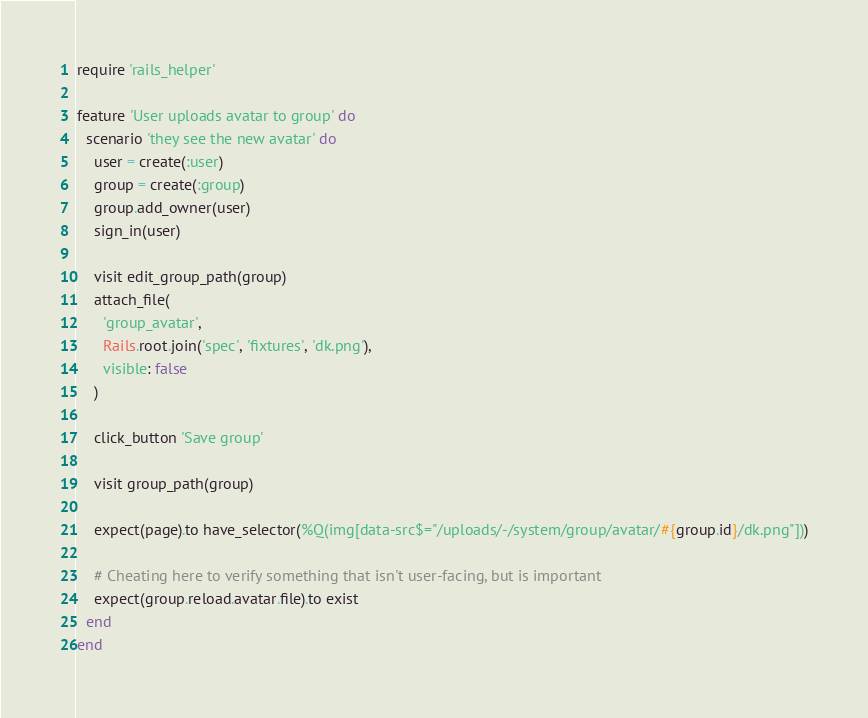<code> <loc_0><loc_0><loc_500><loc_500><_Ruby_>require 'rails_helper'

feature 'User uploads avatar to group' do
  scenario 'they see the new avatar' do
    user = create(:user)
    group = create(:group)
    group.add_owner(user)
    sign_in(user)

    visit edit_group_path(group)
    attach_file(
      'group_avatar',
      Rails.root.join('spec', 'fixtures', 'dk.png'),
      visible: false
    )

    click_button 'Save group'

    visit group_path(group)

    expect(page).to have_selector(%Q(img[data-src$="/uploads/-/system/group/avatar/#{group.id}/dk.png"]))

    # Cheating here to verify something that isn't user-facing, but is important
    expect(group.reload.avatar.file).to exist
  end
end
</code> 